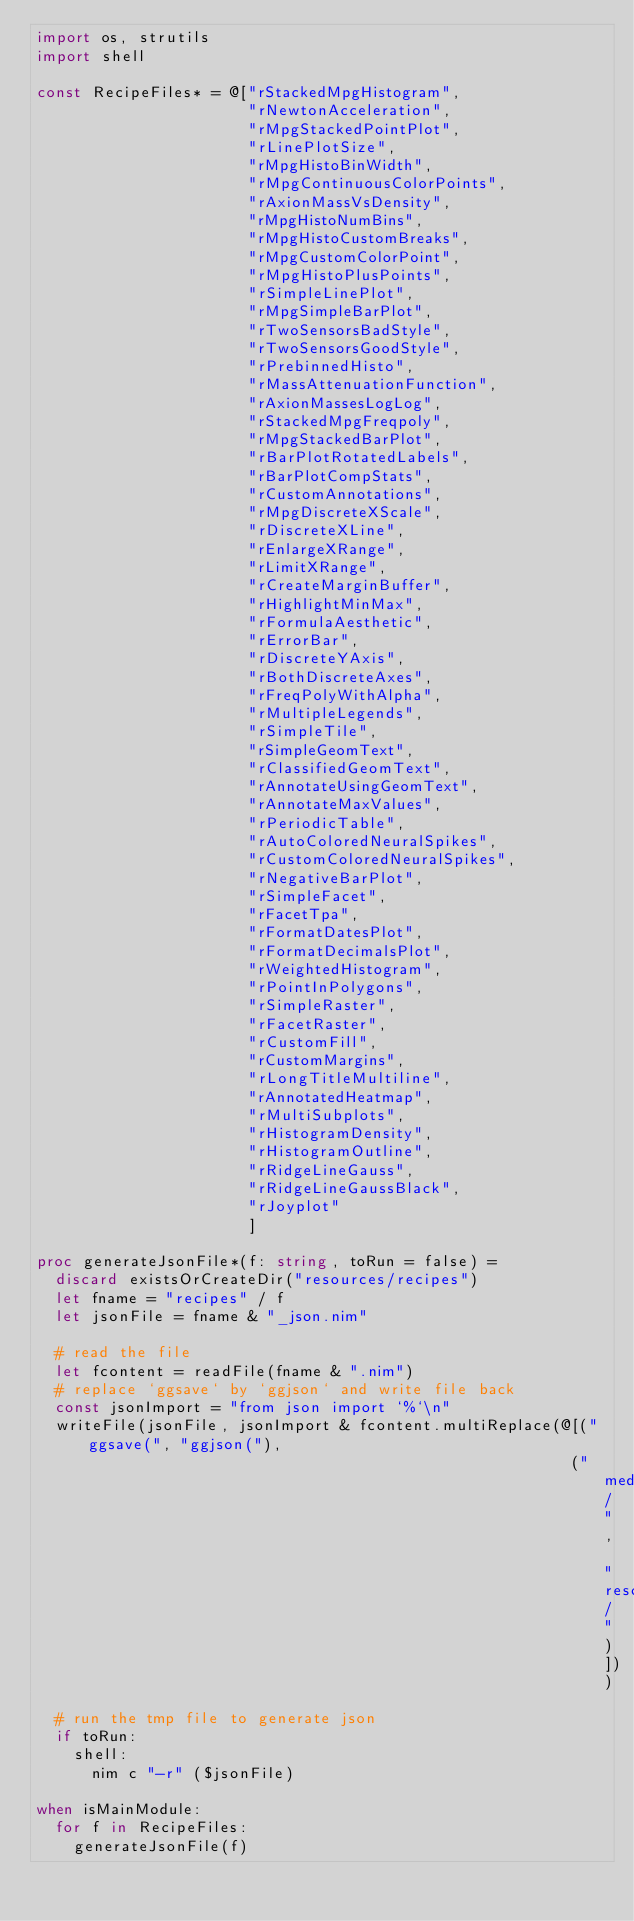Convert code to text. <code><loc_0><loc_0><loc_500><loc_500><_Nim_>import os, strutils
import shell

const RecipeFiles* = @["rStackedMpgHistogram",
                       "rNewtonAcceleration",
                       "rMpgStackedPointPlot",
                       "rLinePlotSize",
                       "rMpgHistoBinWidth",
                       "rMpgContinuousColorPoints",
                       "rAxionMassVsDensity",
                       "rMpgHistoNumBins",
                       "rMpgHistoCustomBreaks",
                       "rMpgCustomColorPoint",
                       "rMpgHistoPlusPoints",
                       "rSimpleLinePlot",
                       "rMpgSimpleBarPlot",
                       "rTwoSensorsBadStyle",
                       "rTwoSensorsGoodStyle",
                       "rPrebinnedHisto",
                       "rMassAttenuationFunction",
                       "rAxionMassesLogLog",
                       "rStackedMpgFreqpoly",
                       "rMpgStackedBarPlot",
                       "rBarPlotRotatedLabels",
                       "rBarPlotCompStats",
                       "rCustomAnnotations",
                       "rMpgDiscreteXScale",
                       "rDiscreteXLine",
                       "rEnlargeXRange",
                       "rLimitXRange",
                       "rCreateMarginBuffer",
                       "rHighlightMinMax",
                       "rFormulaAesthetic",
                       "rErrorBar",
                       "rDiscreteYAxis",
                       "rBothDiscreteAxes",
                       "rFreqPolyWithAlpha",
                       "rMultipleLegends",
                       "rSimpleTile",
                       "rSimpleGeomText",
                       "rClassifiedGeomText",
                       "rAnnotateUsingGeomText",
                       "rAnnotateMaxValues",
                       "rPeriodicTable",
                       "rAutoColoredNeuralSpikes",
                       "rCustomColoredNeuralSpikes",
                       "rNegativeBarPlot",
                       "rSimpleFacet",
                       "rFacetTpa",
                       "rFormatDatesPlot",
                       "rFormatDecimalsPlot",
                       "rWeightedHistogram",
                       "rPointInPolygons",
                       "rSimpleRaster",
                       "rFacetRaster",
                       "rCustomFill",
                       "rCustomMargins",
                       "rLongTitleMultiline",
                       "rAnnotatedHeatmap",
                       "rMultiSubplots",
                       "rHistogramDensity",
                       "rHistogramOutline",
                       "rRidgeLineGauss",
                       "rRidgeLineGaussBlack",
                       "rJoyplot"
                       ]

proc generateJsonFile*(f: string, toRun = false) =
  discard existsOrCreateDir("resources/recipes")
  let fname = "recipes" / f
  let jsonFile = fname & "_json.nim"

  # read the file
  let fcontent = readFile(fname & ".nim")
  # replace `ggsave` by `ggjson` and write file back
  const jsonImport = "from json import `%`\n"
  writeFile(jsonFile, jsonImport & fcontent.multiReplace(@[("ggsave(", "ggjson("),
                                                          ("media/", "resources/")]))
  # run the tmp file to generate json
  if toRun:
    shell:
      nim c "-r" ($jsonFile)

when isMainModule:
  for f in RecipeFiles:
    generateJsonFile(f)
</code> 